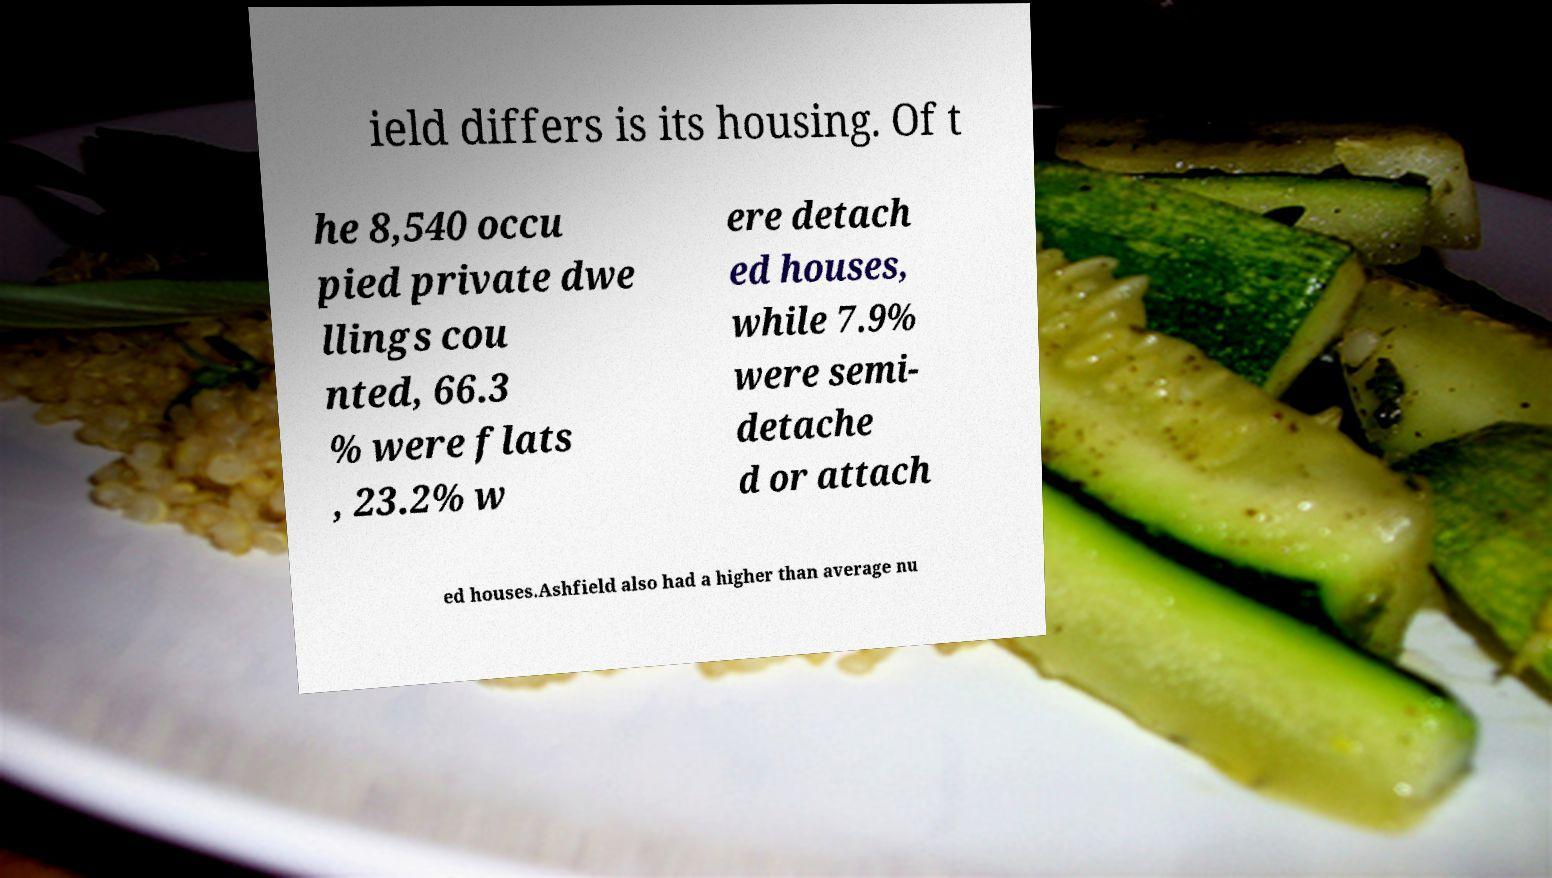Please read and relay the text visible in this image. What does it say? ield differs is its housing. Of t he 8,540 occu pied private dwe llings cou nted, 66.3 % were flats , 23.2% w ere detach ed houses, while 7.9% were semi- detache d or attach ed houses.Ashfield also had a higher than average nu 